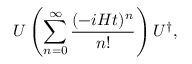Convert formula to latex. <formula><loc_0><loc_0><loc_500><loc_500>U \left ( \sum _ { n = 0 } ^ { \infty } \frac { ( - i H t ) ^ { n } } { n ! } \right ) U ^ { \dagger } ,</formula> 